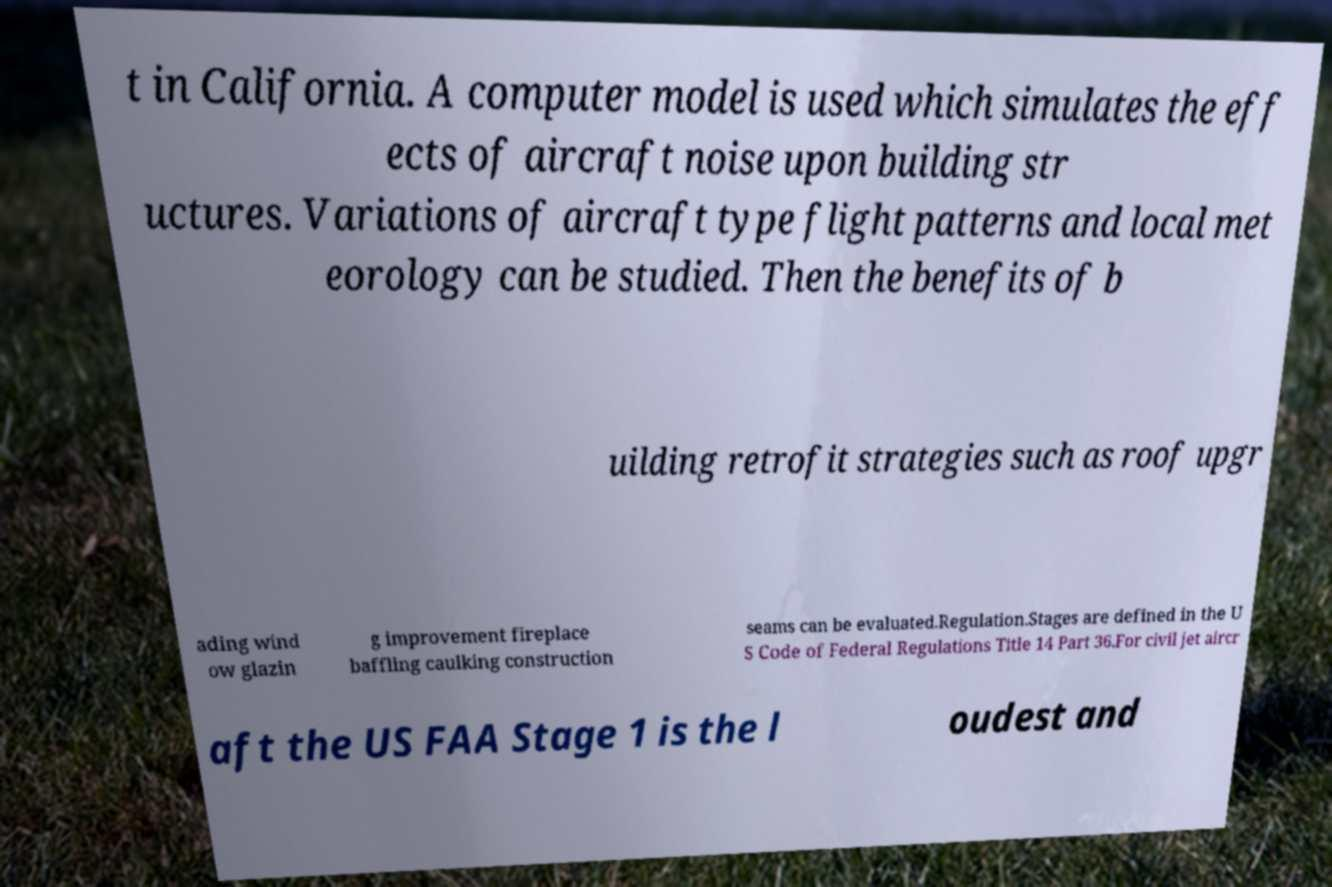Can you read and provide the text displayed in the image?This photo seems to have some interesting text. Can you extract and type it out for me? t in California. A computer model is used which simulates the eff ects of aircraft noise upon building str uctures. Variations of aircraft type flight patterns and local met eorology can be studied. Then the benefits of b uilding retrofit strategies such as roof upgr ading wind ow glazin g improvement fireplace baffling caulking construction seams can be evaluated.Regulation.Stages are defined in the U S Code of Federal Regulations Title 14 Part 36.For civil jet aircr aft the US FAA Stage 1 is the l oudest and 